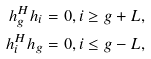Convert formula to latex. <formula><loc_0><loc_0><loc_500><loc_500>h _ { g } ^ { H } h _ { i } = 0 , i \geq { g + L } , \\ h _ { i } ^ { H } h _ { g } = 0 , i \leq { g - L } ,</formula> 